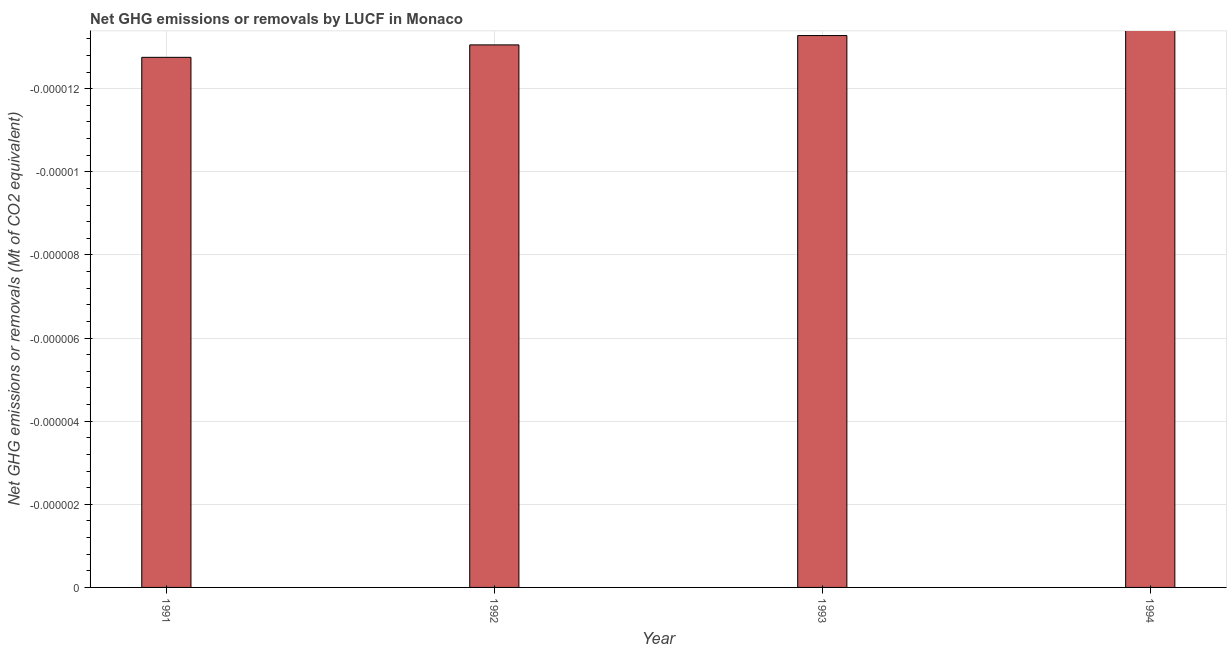Does the graph contain grids?
Your answer should be very brief. Yes. What is the title of the graph?
Offer a terse response. Net GHG emissions or removals by LUCF in Monaco. What is the label or title of the Y-axis?
Your response must be concise. Net GHG emissions or removals (Mt of CO2 equivalent). What is the ghg net emissions or removals in 1992?
Make the answer very short. 0. Across all years, what is the minimum ghg net emissions or removals?
Make the answer very short. 0. What is the median ghg net emissions or removals?
Your response must be concise. 0. In how many years, is the ghg net emissions or removals greater than -8e-07 Mt?
Give a very brief answer. 0. In how many years, is the ghg net emissions or removals greater than the average ghg net emissions or removals taken over all years?
Keep it short and to the point. 0. How many bars are there?
Offer a very short reply. 0. Are all the bars in the graph horizontal?
Your answer should be compact. No. What is the difference between two consecutive major ticks on the Y-axis?
Your answer should be very brief. 1.9999999999999995e-6. What is the Net GHG emissions or removals (Mt of CO2 equivalent) of 1991?
Keep it short and to the point. 0. What is the Net GHG emissions or removals (Mt of CO2 equivalent) of 1992?
Keep it short and to the point. 0. What is the Net GHG emissions or removals (Mt of CO2 equivalent) in 1994?
Provide a short and direct response. 0. 